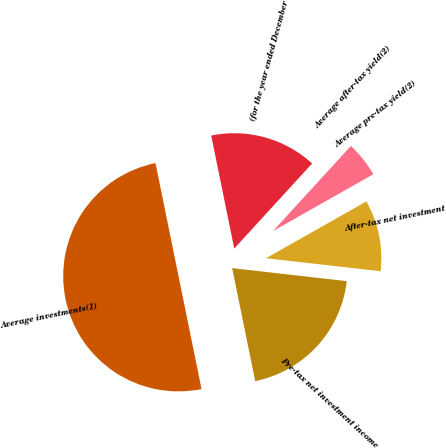Convert chart. <chart><loc_0><loc_0><loc_500><loc_500><pie_chart><fcel>(for the year ended December<fcel>Average investments(1)<fcel>Pre-tax net investment income<fcel>After-tax net investment<fcel>Average pre-tax yield(2)<fcel>Average after-tax yield(2)<nl><fcel>15.0%<fcel>50.0%<fcel>20.0%<fcel>10.0%<fcel>5.0%<fcel>0.0%<nl></chart> 